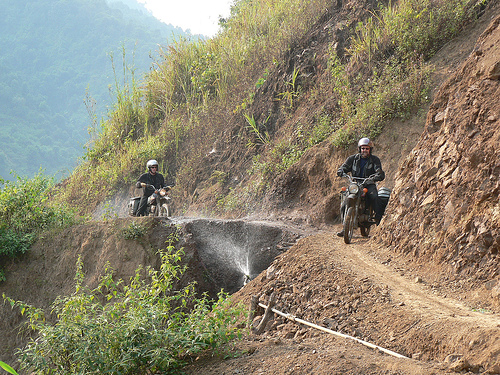Are the details of the ground relatively abundant? Yes, the ground in the image displays a rich tapestry of details. From the rugged, uneven surface of the dirt path to the scattered debris and patches of vegetation, the terrain provides abundant visual information that contributes to the scene's overall rustic and untamed atmosphere. 